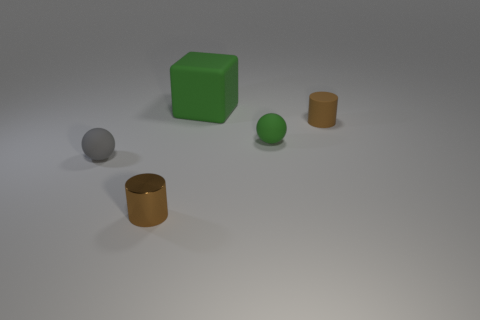If these objects were part of a game, what kind of game do you think it would be? If these objects were in a game, it could be a puzzle or educational type where users might be tasked with sorting or categorizing objects based on size, shape, color, or material. Their simple geometric forms hint towards a game focused on logic, spatial understanding, or learning basic properties of objects. 